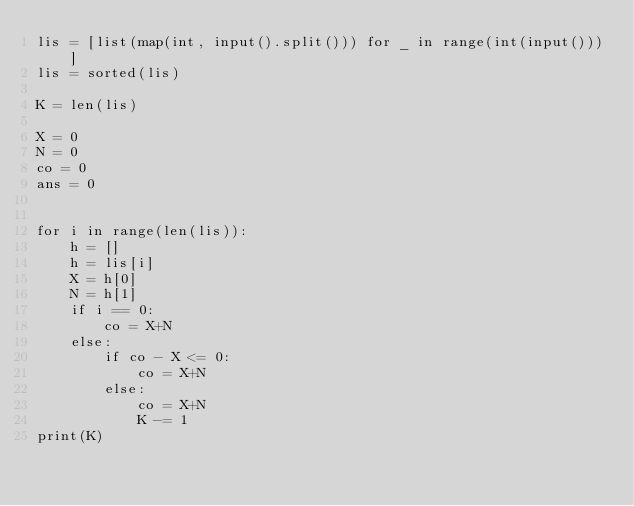Convert code to text. <code><loc_0><loc_0><loc_500><loc_500><_Python_>lis = [list(map(int, input().split())) for _ in range(int(input()))]
lis = sorted(lis)

K = len(lis)

X = 0
N = 0
co = 0
ans = 0


for i in range(len(lis)):
    h = []
    h = lis[i]
    X = h[0]
    N = h[1]
    if i == 0:
        co = X+N
    else:
        if co - X <= 0:
            co = X+N
        else:
            co = X+N
            K -= 1
print(K)


</code> 